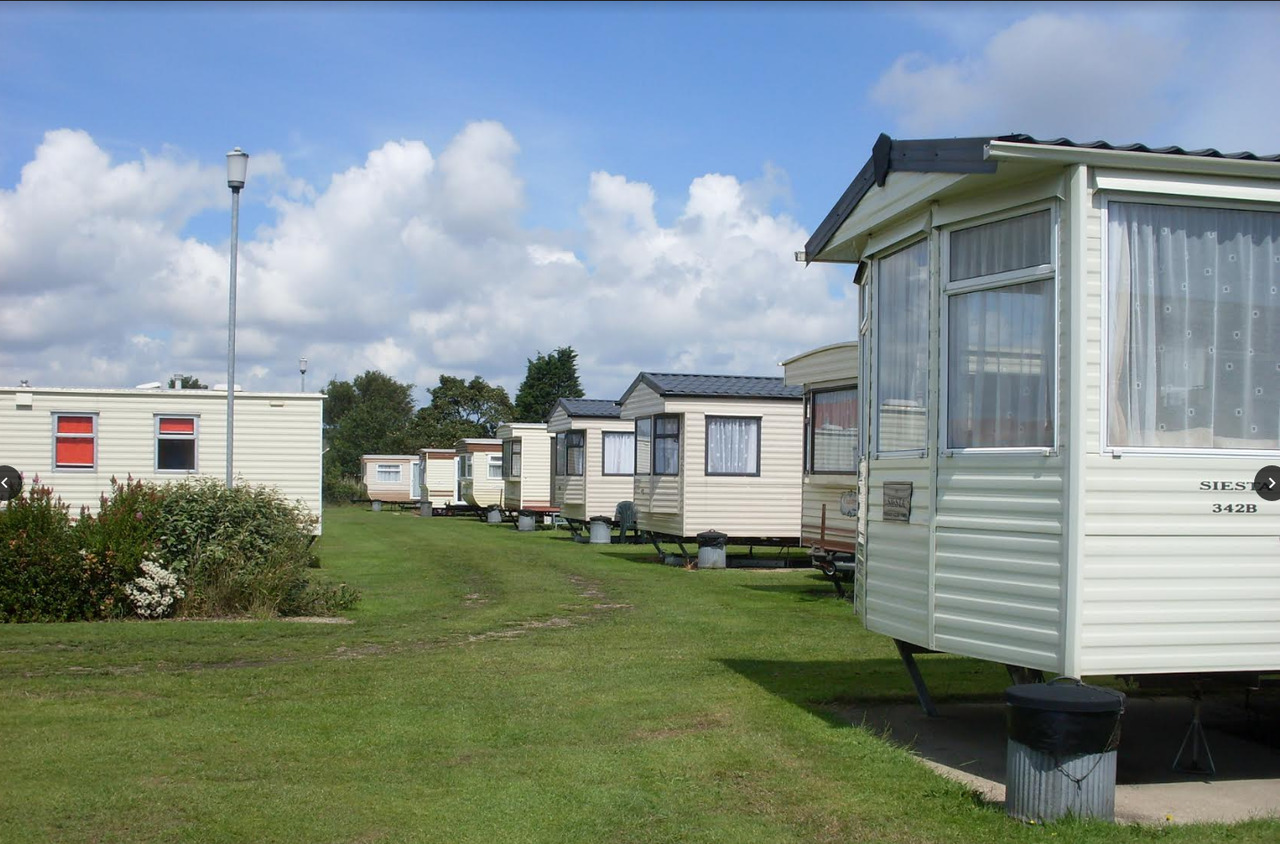Considering the wear on the grass, what could be said about the traffic or movement within the caravan park? The wear on the grass indicates that certain pathways experience regular foot traffic within the caravan park, likely pathways frequently used by the residents and visitors. These worn paths suggest consistent usage, potentially leading to essential facilities, exits, or communal areas within the park. In contrast, areas with more grass cover see less traffic. The absence of paved paths implies a preference for a natural setting or suggests that the park does not experience high levels of foot traffic warranting paved walkways, fitting a serene and nature-friendly environment. 